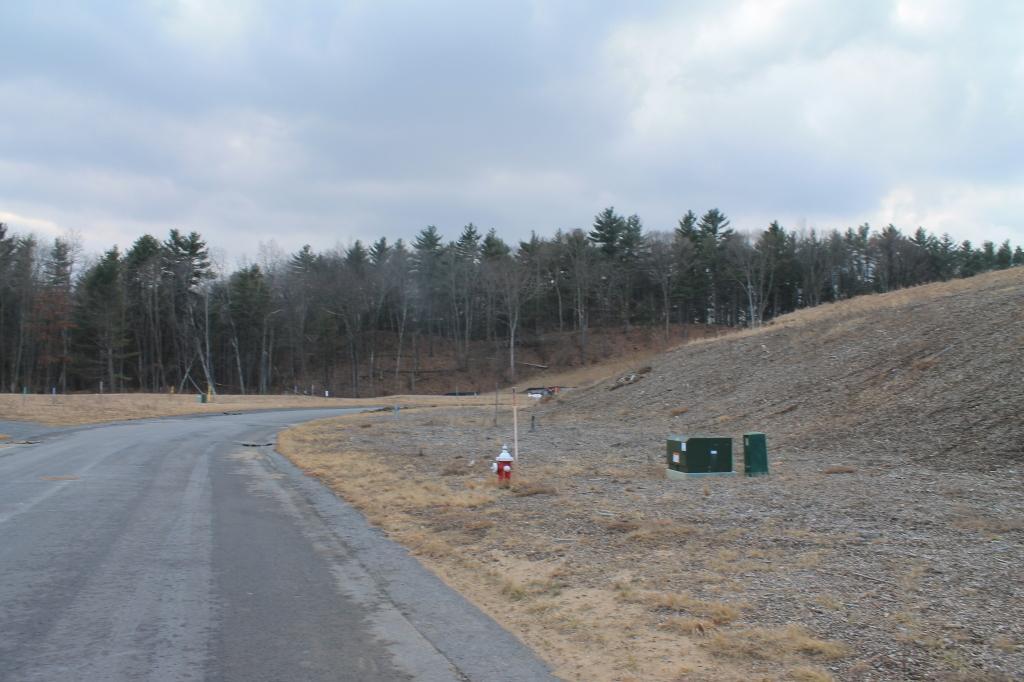Can you describe this image briefly? In this image I can see the road. To the right I can see two boxes and the fire hydrant. In the background I can see the many trees, clouds and the sky. 